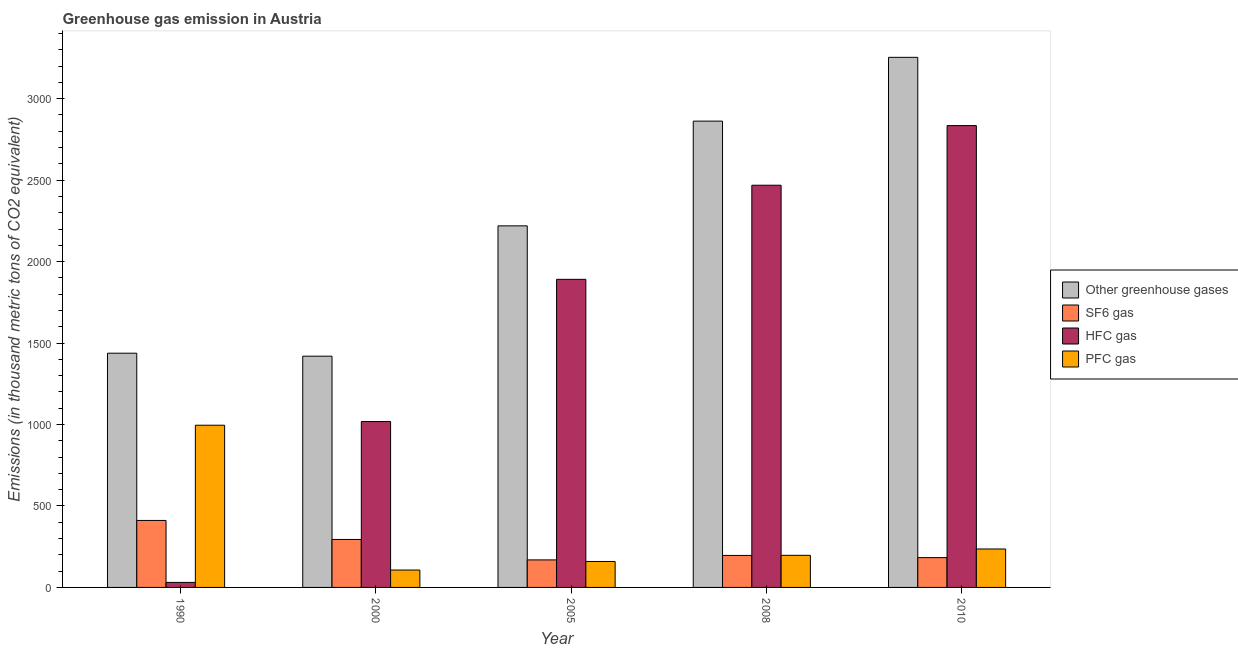How many bars are there on the 4th tick from the left?
Your answer should be very brief. 4. How many bars are there on the 1st tick from the right?
Your answer should be compact. 4. What is the label of the 2nd group of bars from the left?
Make the answer very short. 2000. What is the emission of pfc gas in 2010?
Offer a very short reply. 236. Across all years, what is the maximum emission of greenhouse gases?
Keep it short and to the point. 3254. Across all years, what is the minimum emission of hfc gas?
Your response must be concise. 30.9. In which year was the emission of pfc gas minimum?
Make the answer very short. 2000. What is the total emission of greenhouse gases in the graph?
Provide a short and direct response. 1.12e+04. What is the difference between the emission of hfc gas in 1990 and that in 2005?
Provide a succinct answer. -1860.3. What is the difference between the emission of hfc gas in 2008 and the emission of sf6 gas in 1990?
Your response must be concise. 2438. What is the average emission of sf6 gas per year?
Ensure brevity in your answer.  250.8. What is the ratio of the emission of greenhouse gases in 2000 to that in 2010?
Make the answer very short. 0.44. Is the emission of pfc gas in 1990 less than that in 2000?
Ensure brevity in your answer.  No. Is the difference between the emission of hfc gas in 1990 and 2010 greater than the difference between the emission of greenhouse gases in 1990 and 2010?
Provide a short and direct response. No. What is the difference between the highest and the second highest emission of pfc gas?
Provide a short and direct response. 759.7. What is the difference between the highest and the lowest emission of sf6 gas?
Provide a succinct answer. 242.2. What does the 3rd bar from the left in 2000 represents?
Provide a succinct answer. HFC gas. What does the 4th bar from the right in 2010 represents?
Provide a succinct answer. Other greenhouse gases. Is it the case that in every year, the sum of the emission of greenhouse gases and emission of sf6 gas is greater than the emission of hfc gas?
Your answer should be very brief. Yes. Are the values on the major ticks of Y-axis written in scientific E-notation?
Provide a succinct answer. No. Does the graph contain any zero values?
Ensure brevity in your answer.  No. Does the graph contain grids?
Your answer should be compact. No. How many legend labels are there?
Offer a very short reply. 4. What is the title of the graph?
Ensure brevity in your answer.  Greenhouse gas emission in Austria. Does "Secondary schools" appear as one of the legend labels in the graph?
Your answer should be compact. No. What is the label or title of the X-axis?
Ensure brevity in your answer.  Year. What is the label or title of the Y-axis?
Ensure brevity in your answer.  Emissions (in thousand metric tons of CO2 equivalent). What is the Emissions (in thousand metric tons of CO2 equivalent) in Other greenhouse gases in 1990?
Provide a short and direct response. 1437.8. What is the Emissions (in thousand metric tons of CO2 equivalent) of SF6 gas in 1990?
Offer a very short reply. 411.2. What is the Emissions (in thousand metric tons of CO2 equivalent) of HFC gas in 1990?
Provide a short and direct response. 30.9. What is the Emissions (in thousand metric tons of CO2 equivalent) in PFC gas in 1990?
Ensure brevity in your answer.  995.7. What is the Emissions (in thousand metric tons of CO2 equivalent) of Other greenhouse gases in 2000?
Provide a short and direct response. 1419.5. What is the Emissions (in thousand metric tons of CO2 equivalent) in SF6 gas in 2000?
Your response must be concise. 294.4. What is the Emissions (in thousand metric tons of CO2 equivalent) in HFC gas in 2000?
Make the answer very short. 1018.4. What is the Emissions (in thousand metric tons of CO2 equivalent) in PFC gas in 2000?
Offer a very short reply. 106.7. What is the Emissions (in thousand metric tons of CO2 equivalent) of Other greenhouse gases in 2005?
Your answer should be very brief. 2219.5. What is the Emissions (in thousand metric tons of CO2 equivalent) of SF6 gas in 2005?
Your answer should be very brief. 169. What is the Emissions (in thousand metric tons of CO2 equivalent) in HFC gas in 2005?
Offer a terse response. 1891.2. What is the Emissions (in thousand metric tons of CO2 equivalent) of PFC gas in 2005?
Offer a terse response. 159.3. What is the Emissions (in thousand metric tons of CO2 equivalent) of Other greenhouse gases in 2008?
Make the answer very short. 2862.4. What is the Emissions (in thousand metric tons of CO2 equivalent) of SF6 gas in 2008?
Keep it short and to the point. 196.4. What is the Emissions (in thousand metric tons of CO2 equivalent) in HFC gas in 2008?
Your response must be concise. 2468.9. What is the Emissions (in thousand metric tons of CO2 equivalent) of PFC gas in 2008?
Offer a very short reply. 197.1. What is the Emissions (in thousand metric tons of CO2 equivalent) of Other greenhouse gases in 2010?
Your response must be concise. 3254. What is the Emissions (in thousand metric tons of CO2 equivalent) in SF6 gas in 2010?
Provide a short and direct response. 183. What is the Emissions (in thousand metric tons of CO2 equivalent) of HFC gas in 2010?
Keep it short and to the point. 2835. What is the Emissions (in thousand metric tons of CO2 equivalent) of PFC gas in 2010?
Offer a very short reply. 236. Across all years, what is the maximum Emissions (in thousand metric tons of CO2 equivalent) of Other greenhouse gases?
Your answer should be very brief. 3254. Across all years, what is the maximum Emissions (in thousand metric tons of CO2 equivalent) in SF6 gas?
Your answer should be compact. 411.2. Across all years, what is the maximum Emissions (in thousand metric tons of CO2 equivalent) in HFC gas?
Your answer should be very brief. 2835. Across all years, what is the maximum Emissions (in thousand metric tons of CO2 equivalent) of PFC gas?
Your answer should be compact. 995.7. Across all years, what is the minimum Emissions (in thousand metric tons of CO2 equivalent) in Other greenhouse gases?
Your response must be concise. 1419.5. Across all years, what is the minimum Emissions (in thousand metric tons of CO2 equivalent) in SF6 gas?
Your response must be concise. 169. Across all years, what is the minimum Emissions (in thousand metric tons of CO2 equivalent) of HFC gas?
Give a very brief answer. 30.9. Across all years, what is the minimum Emissions (in thousand metric tons of CO2 equivalent) of PFC gas?
Offer a terse response. 106.7. What is the total Emissions (in thousand metric tons of CO2 equivalent) in Other greenhouse gases in the graph?
Ensure brevity in your answer.  1.12e+04. What is the total Emissions (in thousand metric tons of CO2 equivalent) of SF6 gas in the graph?
Keep it short and to the point. 1254. What is the total Emissions (in thousand metric tons of CO2 equivalent) of HFC gas in the graph?
Provide a succinct answer. 8244.4. What is the total Emissions (in thousand metric tons of CO2 equivalent) of PFC gas in the graph?
Offer a very short reply. 1694.8. What is the difference between the Emissions (in thousand metric tons of CO2 equivalent) in Other greenhouse gases in 1990 and that in 2000?
Provide a short and direct response. 18.3. What is the difference between the Emissions (in thousand metric tons of CO2 equivalent) in SF6 gas in 1990 and that in 2000?
Offer a terse response. 116.8. What is the difference between the Emissions (in thousand metric tons of CO2 equivalent) in HFC gas in 1990 and that in 2000?
Provide a succinct answer. -987.5. What is the difference between the Emissions (in thousand metric tons of CO2 equivalent) in PFC gas in 1990 and that in 2000?
Ensure brevity in your answer.  889. What is the difference between the Emissions (in thousand metric tons of CO2 equivalent) in Other greenhouse gases in 1990 and that in 2005?
Ensure brevity in your answer.  -781.7. What is the difference between the Emissions (in thousand metric tons of CO2 equivalent) in SF6 gas in 1990 and that in 2005?
Your response must be concise. 242.2. What is the difference between the Emissions (in thousand metric tons of CO2 equivalent) of HFC gas in 1990 and that in 2005?
Your response must be concise. -1860.3. What is the difference between the Emissions (in thousand metric tons of CO2 equivalent) in PFC gas in 1990 and that in 2005?
Your response must be concise. 836.4. What is the difference between the Emissions (in thousand metric tons of CO2 equivalent) of Other greenhouse gases in 1990 and that in 2008?
Offer a terse response. -1424.6. What is the difference between the Emissions (in thousand metric tons of CO2 equivalent) in SF6 gas in 1990 and that in 2008?
Give a very brief answer. 214.8. What is the difference between the Emissions (in thousand metric tons of CO2 equivalent) of HFC gas in 1990 and that in 2008?
Give a very brief answer. -2438. What is the difference between the Emissions (in thousand metric tons of CO2 equivalent) of PFC gas in 1990 and that in 2008?
Provide a short and direct response. 798.6. What is the difference between the Emissions (in thousand metric tons of CO2 equivalent) of Other greenhouse gases in 1990 and that in 2010?
Your answer should be very brief. -1816.2. What is the difference between the Emissions (in thousand metric tons of CO2 equivalent) of SF6 gas in 1990 and that in 2010?
Provide a succinct answer. 228.2. What is the difference between the Emissions (in thousand metric tons of CO2 equivalent) in HFC gas in 1990 and that in 2010?
Give a very brief answer. -2804.1. What is the difference between the Emissions (in thousand metric tons of CO2 equivalent) of PFC gas in 1990 and that in 2010?
Your response must be concise. 759.7. What is the difference between the Emissions (in thousand metric tons of CO2 equivalent) of Other greenhouse gases in 2000 and that in 2005?
Keep it short and to the point. -800. What is the difference between the Emissions (in thousand metric tons of CO2 equivalent) of SF6 gas in 2000 and that in 2005?
Provide a short and direct response. 125.4. What is the difference between the Emissions (in thousand metric tons of CO2 equivalent) in HFC gas in 2000 and that in 2005?
Provide a succinct answer. -872.8. What is the difference between the Emissions (in thousand metric tons of CO2 equivalent) of PFC gas in 2000 and that in 2005?
Your answer should be very brief. -52.6. What is the difference between the Emissions (in thousand metric tons of CO2 equivalent) in Other greenhouse gases in 2000 and that in 2008?
Your answer should be very brief. -1442.9. What is the difference between the Emissions (in thousand metric tons of CO2 equivalent) in HFC gas in 2000 and that in 2008?
Give a very brief answer. -1450.5. What is the difference between the Emissions (in thousand metric tons of CO2 equivalent) of PFC gas in 2000 and that in 2008?
Offer a terse response. -90.4. What is the difference between the Emissions (in thousand metric tons of CO2 equivalent) of Other greenhouse gases in 2000 and that in 2010?
Your answer should be very brief. -1834.5. What is the difference between the Emissions (in thousand metric tons of CO2 equivalent) in SF6 gas in 2000 and that in 2010?
Provide a short and direct response. 111.4. What is the difference between the Emissions (in thousand metric tons of CO2 equivalent) of HFC gas in 2000 and that in 2010?
Offer a very short reply. -1816.6. What is the difference between the Emissions (in thousand metric tons of CO2 equivalent) of PFC gas in 2000 and that in 2010?
Offer a very short reply. -129.3. What is the difference between the Emissions (in thousand metric tons of CO2 equivalent) in Other greenhouse gases in 2005 and that in 2008?
Make the answer very short. -642.9. What is the difference between the Emissions (in thousand metric tons of CO2 equivalent) of SF6 gas in 2005 and that in 2008?
Your answer should be very brief. -27.4. What is the difference between the Emissions (in thousand metric tons of CO2 equivalent) of HFC gas in 2005 and that in 2008?
Provide a short and direct response. -577.7. What is the difference between the Emissions (in thousand metric tons of CO2 equivalent) in PFC gas in 2005 and that in 2008?
Offer a terse response. -37.8. What is the difference between the Emissions (in thousand metric tons of CO2 equivalent) in Other greenhouse gases in 2005 and that in 2010?
Keep it short and to the point. -1034.5. What is the difference between the Emissions (in thousand metric tons of CO2 equivalent) of HFC gas in 2005 and that in 2010?
Give a very brief answer. -943.8. What is the difference between the Emissions (in thousand metric tons of CO2 equivalent) of PFC gas in 2005 and that in 2010?
Provide a succinct answer. -76.7. What is the difference between the Emissions (in thousand metric tons of CO2 equivalent) of Other greenhouse gases in 2008 and that in 2010?
Give a very brief answer. -391.6. What is the difference between the Emissions (in thousand metric tons of CO2 equivalent) of SF6 gas in 2008 and that in 2010?
Keep it short and to the point. 13.4. What is the difference between the Emissions (in thousand metric tons of CO2 equivalent) in HFC gas in 2008 and that in 2010?
Give a very brief answer. -366.1. What is the difference between the Emissions (in thousand metric tons of CO2 equivalent) in PFC gas in 2008 and that in 2010?
Offer a terse response. -38.9. What is the difference between the Emissions (in thousand metric tons of CO2 equivalent) of Other greenhouse gases in 1990 and the Emissions (in thousand metric tons of CO2 equivalent) of SF6 gas in 2000?
Offer a terse response. 1143.4. What is the difference between the Emissions (in thousand metric tons of CO2 equivalent) of Other greenhouse gases in 1990 and the Emissions (in thousand metric tons of CO2 equivalent) of HFC gas in 2000?
Offer a very short reply. 419.4. What is the difference between the Emissions (in thousand metric tons of CO2 equivalent) of Other greenhouse gases in 1990 and the Emissions (in thousand metric tons of CO2 equivalent) of PFC gas in 2000?
Ensure brevity in your answer.  1331.1. What is the difference between the Emissions (in thousand metric tons of CO2 equivalent) in SF6 gas in 1990 and the Emissions (in thousand metric tons of CO2 equivalent) in HFC gas in 2000?
Your response must be concise. -607.2. What is the difference between the Emissions (in thousand metric tons of CO2 equivalent) of SF6 gas in 1990 and the Emissions (in thousand metric tons of CO2 equivalent) of PFC gas in 2000?
Make the answer very short. 304.5. What is the difference between the Emissions (in thousand metric tons of CO2 equivalent) in HFC gas in 1990 and the Emissions (in thousand metric tons of CO2 equivalent) in PFC gas in 2000?
Your response must be concise. -75.8. What is the difference between the Emissions (in thousand metric tons of CO2 equivalent) in Other greenhouse gases in 1990 and the Emissions (in thousand metric tons of CO2 equivalent) in SF6 gas in 2005?
Your answer should be compact. 1268.8. What is the difference between the Emissions (in thousand metric tons of CO2 equivalent) of Other greenhouse gases in 1990 and the Emissions (in thousand metric tons of CO2 equivalent) of HFC gas in 2005?
Provide a short and direct response. -453.4. What is the difference between the Emissions (in thousand metric tons of CO2 equivalent) of Other greenhouse gases in 1990 and the Emissions (in thousand metric tons of CO2 equivalent) of PFC gas in 2005?
Offer a terse response. 1278.5. What is the difference between the Emissions (in thousand metric tons of CO2 equivalent) in SF6 gas in 1990 and the Emissions (in thousand metric tons of CO2 equivalent) in HFC gas in 2005?
Provide a short and direct response. -1480. What is the difference between the Emissions (in thousand metric tons of CO2 equivalent) in SF6 gas in 1990 and the Emissions (in thousand metric tons of CO2 equivalent) in PFC gas in 2005?
Offer a terse response. 251.9. What is the difference between the Emissions (in thousand metric tons of CO2 equivalent) of HFC gas in 1990 and the Emissions (in thousand metric tons of CO2 equivalent) of PFC gas in 2005?
Offer a very short reply. -128.4. What is the difference between the Emissions (in thousand metric tons of CO2 equivalent) of Other greenhouse gases in 1990 and the Emissions (in thousand metric tons of CO2 equivalent) of SF6 gas in 2008?
Your answer should be compact. 1241.4. What is the difference between the Emissions (in thousand metric tons of CO2 equivalent) in Other greenhouse gases in 1990 and the Emissions (in thousand metric tons of CO2 equivalent) in HFC gas in 2008?
Offer a very short reply. -1031.1. What is the difference between the Emissions (in thousand metric tons of CO2 equivalent) in Other greenhouse gases in 1990 and the Emissions (in thousand metric tons of CO2 equivalent) in PFC gas in 2008?
Provide a short and direct response. 1240.7. What is the difference between the Emissions (in thousand metric tons of CO2 equivalent) in SF6 gas in 1990 and the Emissions (in thousand metric tons of CO2 equivalent) in HFC gas in 2008?
Give a very brief answer. -2057.7. What is the difference between the Emissions (in thousand metric tons of CO2 equivalent) in SF6 gas in 1990 and the Emissions (in thousand metric tons of CO2 equivalent) in PFC gas in 2008?
Your answer should be very brief. 214.1. What is the difference between the Emissions (in thousand metric tons of CO2 equivalent) in HFC gas in 1990 and the Emissions (in thousand metric tons of CO2 equivalent) in PFC gas in 2008?
Provide a succinct answer. -166.2. What is the difference between the Emissions (in thousand metric tons of CO2 equivalent) of Other greenhouse gases in 1990 and the Emissions (in thousand metric tons of CO2 equivalent) of SF6 gas in 2010?
Offer a very short reply. 1254.8. What is the difference between the Emissions (in thousand metric tons of CO2 equivalent) in Other greenhouse gases in 1990 and the Emissions (in thousand metric tons of CO2 equivalent) in HFC gas in 2010?
Offer a very short reply. -1397.2. What is the difference between the Emissions (in thousand metric tons of CO2 equivalent) of Other greenhouse gases in 1990 and the Emissions (in thousand metric tons of CO2 equivalent) of PFC gas in 2010?
Ensure brevity in your answer.  1201.8. What is the difference between the Emissions (in thousand metric tons of CO2 equivalent) of SF6 gas in 1990 and the Emissions (in thousand metric tons of CO2 equivalent) of HFC gas in 2010?
Your answer should be very brief. -2423.8. What is the difference between the Emissions (in thousand metric tons of CO2 equivalent) in SF6 gas in 1990 and the Emissions (in thousand metric tons of CO2 equivalent) in PFC gas in 2010?
Give a very brief answer. 175.2. What is the difference between the Emissions (in thousand metric tons of CO2 equivalent) of HFC gas in 1990 and the Emissions (in thousand metric tons of CO2 equivalent) of PFC gas in 2010?
Keep it short and to the point. -205.1. What is the difference between the Emissions (in thousand metric tons of CO2 equivalent) in Other greenhouse gases in 2000 and the Emissions (in thousand metric tons of CO2 equivalent) in SF6 gas in 2005?
Give a very brief answer. 1250.5. What is the difference between the Emissions (in thousand metric tons of CO2 equivalent) of Other greenhouse gases in 2000 and the Emissions (in thousand metric tons of CO2 equivalent) of HFC gas in 2005?
Your answer should be very brief. -471.7. What is the difference between the Emissions (in thousand metric tons of CO2 equivalent) in Other greenhouse gases in 2000 and the Emissions (in thousand metric tons of CO2 equivalent) in PFC gas in 2005?
Ensure brevity in your answer.  1260.2. What is the difference between the Emissions (in thousand metric tons of CO2 equivalent) in SF6 gas in 2000 and the Emissions (in thousand metric tons of CO2 equivalent) in HFC gas in 2005?
Offer a very short reply. -1596.8. What is the difference between the Emissions (in thousand metric tons of CO2 equivalent) of SF6 gas in 2000 and the Emissions (in thousand metric tons of CO2 equivalent) of PFC gas in 2005?
Your response must be concise. 135.1. What is the difference between the Emissions (in thousand metric tons of CO2 equivalent) in HFC gas in 2000 and the Emissions (in thousand metric tons of CO2 equivalent) in PFC gas in 2005?
Provide a short and direct response. 859.1. What is the difference between the Emissions (in thousand metric tons of CO2 equivalent) of Other greenhouse gases in 2000 and the Emissions (in thousand metric tons of CO2 equivalent) of SF6 gas in 2008?
Offer a terse response. 1223.1. What is the difference between the Emissions (in thousand metric tons of CO2 equivalent) of Other greenhouse gases in 2000 and the Emissions (in thousand metric tons of CO2 equivalent) of HFC gas in 2008?
Your answer should be very brief. -1049.4. What is the difference between the Emissions (in thousand metric tons of CO2 equivalent) in Other greenhouse gases in 2000 and the Emissions (in thousand metric tons of CO2 equivalent) in PFC gas in 2008?
Provide a short and direct response. 1222.4. What is the difference between the Emissions (in thousand metric tons of CO2 equivalent) in SF6 gas in 2000 and the Emissions (in thousand metric tons of CO2 equivalent) in HFC gas in 2008?
Provide a succinct answer. -2174.5. What is the difference between the Emissions (in thousand metric tons of CO2 equivalent) in SF6 gas in 2000 and the Emissions (in thousand metric tons of CO2 equivalent) in PFC gas in 2008?
Provide a succinct answer. 97.3. What is the difference between the Emissions (in thousand metric tons of CO2 equivalent) in HFC gas in 2000 and the Emissions (in thousand metric tons of CO2 equivalent) in PFC gas in 2008?
Make the answer very short. 821.3. What is the difference between the Emissions (in thousand metric tons of CO2 equivalent) in Other greenhouse gases in 2000 and the Emissions (in thousand metric tons of CO2 equivalent) in SF6 gas in 2010?
Your answer should be compact. 1236.5. What is the difference between the Emissions (in thousand metric tons of CO2 equivalent) in Other greenhouse gases in 2000 and the Emissions (in thousand metric tons of CO2 equivalent) in HFC gas in 2010?
Your answer should be compact. -1415.5. What is the difference between the Emissions (in thousand metric tons of CO2 equivalent) in Other greenhouse gases in 2000 and the Emissions (in thousand metric tons of CO2 equivalent) in PFC gas in 2010?
Offer a very short reply. 1183.5. What is the difference between the Emissions (in thousand metric tons of CO2 equivalent) in SF6 gas in 2000 and the Emissions (in thousand metric tons of CO2 equivalent) in HFC gas in 2010?
Give a very brief answer. -2540.6. What is the difference between the Emissions (in thousand metric tons of CO2 equivalent) of SF6 gas in 2000 and the Emissions (in thousand metric tons of CO2 equivalent) of PFC gas in 2010?
Keep it short and to the point. 58.4. What is the difference between the Emissions (in thousand metric tons of CO2 equivalent) of HFC gas in 2000 and the Emissions (in thousand metric tons of CO2 equivalent) of PFC gas in 2010?
Provide a succinct answer. 782.4. What is the difference between the Emissions (in thousand metric tons of CO2 equivalent) of Other greenhouse gases in 2005 and the Emissions (in thousand metric tons of CO2 equivalent) of SF6 gas in 2008?
Your response must be concise. 2023.1. What is the difference between the Emissions (in thousand metric tons of CO2 equivalent) of Other greenhouse gases in 2005 and the Emissions (in thousand metric tons of CO2 equivalent) of HFC gas in 2008?
Ensure brevity in your answer.  -249.4. What is the difference between the Emissions (in thousand metric tons of CO2 equivalent) of Other greenhouse gases in 2005 and the Emissions (in thousand metric tons of CO2 equivalent) of PFC gas in 2008?
Offer a terse response. 2022.4. What is the difference between the Emissions (in thousand metric tons of CO2 equivalent) of SF6 gas in 2005 and the Emissions (in thousand metric tons of CO2 equivalent) of HFC gas in 2008?
Your response must be concise. -2299.9. What is the difference between the Emissions (in thousand metric tons of CO2 equivalent) of SF6 gas in 2005 and the Emissions (in thousand metric tons of CO2 equivalent) of PFC gas in 2008?
Offer a very short reply. -28.1. What is the difference between the Emissions (in thousand metric tons of CO2 equivalent) of HFC gas in 2005 and the Emissions (in thousand metric tons of CO2 equivalent) of PFC gas in 2008?
Offer a very short reply. 1694.1. What is the difference between the Emissions (in thousand metric tons of CO2 equivalent) of Other greenhouse gases in 2005 and the Emissions (in thousand metric tons of CO2 equivalent) of SF6 gas in 2010?
Your answer should be very brief. 2036.5. What is the difference between the Emissions (in thousand metric tons of CO2 equivalent) of Other greenhouse gases in 2005 and the Emissions (in thousand metric tons of CO2 equivalent) of HFC gas in 2010?
Provide a succinct answer. -615.5. What is the difference between the Emissions (in thousand metric tons of CO2 equivalent) of Other greenhouse gases in 2005 and the Emissions (in thousand metric tons of CO2 equivalent) of PFC gas in 2010?
Provide a short and direct response. 1983.5. What is the difference between the Emissions (in thousand metric tons of CO2 equivalent) of SF6 gas in 2005 and the Emissions (in thousand metric tons of CO2 equivalent) of HFC gas in 2010?
Your response must be concise. -2666. What is the difference between the Emissions (in thousand metric tons of CO2 equivalent) in SF6 gas in 2005 and the Emissions (in thousand metric tons of CO2 equivalent) in PFC gas in 2010?
Provide a succinct answer. -67. What is the difference between the Emissions (in thousand metric tons of CO2 equivalent) of HFC gas in 2005 and the Emissions (in thousand metric tons of CO2 equivalent) of PFC gas in 2010?
Provide a short and direct response. 1655.2. What is the difference between the Emissions (in thousand metric tons of CO2 equivalent) in Other greenhouse gases in 2008 and the Emissions (in thousand metric tons of CO2 equivalent) in SF6 gas in 2010?
Your answer should be very brief. 2679.4. What is the difference between the Emissions (in thousand metric tons of CO2 equivalent) in Other greenhouse gases in 2008 and the Emissions (in thousand metric tons of CO2 equivalent) in HFC gas in 2010?
Offer a terse response. 27.4. What is the difference between the Emissions (in thousand metric tons of CO2 equivalent) of Other greenhouse gases in 2008 and the Emissions (in thousand metric tons of CO2 equivalent) of PFC gas in 2010?
Your answer should be very brief. 2626.4. What is the difference between the Emissions (in thousand metric tons of CO2 equivalent) of SF6 gas in 2008 and the Emissions (in thousand metric tons of CO2 equivalent) of HFC gas in 2010?
Ensure brevity in your answer.  -2638.6. What is the difference between the Emissions (in thousand metric tons of CO2 equivalent) in SF6 gas in 2008 and the Emissions (in thousand metric tons of CO2 equivalent) in PFC gas in 2010?
Your answer should be very brief. -39.6. What is the difference between the Emissions (in thousand metric tons of CO2 equivalent) in HFC gas in 2008 and the Emissions (in thousand metric tons of CO2 equivalent) in PFC gas in 2010?
Your answer should be very brief. 2232.9. What is the average Emissions (in thousand metric tons of CO2 equivalent) of Other greenhouse gases per year?
Your answer should be compact. 2238.64. What is the average Emissions (in thousand metric tons of CO2 equivalent) of SF6 gas per year?
Your response must be concise. 250.8. What is the average Emissions (in thousand metric tons of CO2 equivalent) of HFC gas per year?
Provide a short and direct response. 1648.88. What is the average Emissions (in thousand metric tons of CO2 equivalent) of PFC gas per year?
Offer a very short reply. 338.96. In the year 1990, what is the difference between the Emissions (in thousand metric tons of CO2 equivalent) of Other greenhouse gases and Emissions (in thousand metric tons of CO2 equivalent) of SF6 gas?
Offer a very short reply. 1026.6. In the year 1990, what is the difference between the Emissions (in thousand metric tons of CO2 equivalent) of Other greenhouse gases and Emissions (in thousand metric tons of CO2 equivalent) of HFC gas?
Your answer should be compact. 1406.9. In the year 1990, what is the difference between the Emissions (in thousand metric tons of CO2 equivalent) in Other greenhouse gases and Emissions (in thousand metric tons of CO2 equivalent) in PFC gas?
Provide a short and direct response. 442.1. In the year 1990, what is the difference between the Emissions (in thousand metric tons of CO2 equivalent) of SF6 gas and Emissions (in thousand metric tons of CO2 equivalent) of HFC gas?
Your answer should be very brief. 380.3. In the year 1990, what is the difference between the Emissions (in thousand metric tons of CO2 equivalent) in SF6 gas and Emissions (in thousand metric tons of CO2 equivalent) in PFC gas?
Ensure brevity in your answer.  -584.5. In the year 1990, what is the difference between the Emissions (in thousand metric tons of CO2 equivalent) in HFC gas and Emissions (in thousand metric tons of CO2 equivalent) in PFC gas?
Your response must be concise. -964.8. In the year 2000, what is the difference between the Emissions (in thousand metric tons of CO2 equivalent) in Other greenhouse gases and Emissions (in thousand metric tons of CO2 equivalent) in SF6 gas?
Your answer should be very brief. 1125.1. In the year 2000, what is the difference between the Emissions (in thousand metric tons of CO2 equivalent) of Other greenhouse gases and Emissions (in thousand metric tons of CO2 equivalent) of HFC gas?
Your response must be concise. 401.1. In the year 2000, what is the difference between the Emissions (in thousand metric tons of CO2 equivalent) of Other greenhouse gases and Emissions (in thousand metric tons of CO2 equivalent) of PFC gas?
Your answer should be compact. 1312.8. In the year 2000, what is the difference between the Emissions (in thousand metric tons of CO2 equivalent) of SF6 gas and Emissions (in thousand metric tons of CO2 equivalent) of HFC gas?
Keep it short and to the point. -724. In the year 2000, what is the difference between the Emissions (in thousand metric tons of CO2 equivalent) of SF6 gas and Emissions (in thousand metric tons of CO2 equivalent) of PFC gas?
Keep it short and to the point. 187.7. In the year 2000, what is the difference between the Emissions (in thousand metric tons of CO2 equivalent) of HFC gas and Emissions (in thousand metric tons of CO2 equivalent) of PFC gas?
Provide a succinct answer. 911.7. In the year 2005, what is the difference between the Emissions (in thousand metric tons of CO2 equivalent) of Other greenhouse gases and Emissions (in thousand metric tons of CO2 equivalent) of SF6 gas?
Offer a terse response. 2050.5. In the year 2005, what is the difference between the Emissions (in thousand metric tons of CO2 equivalent) in Other greenhouse gases and Emissions (in thousand metric tons of CO2 equivalent) in HFC gas?
Make the answer very short. 328.3. In the year 2005, what is the difference between the Emissions (in thousand metric tons of CO2 equivalent) of Other greenhouse gases and Emissions (in thousand metric tons of CO2 equivalent) of PFC gas?
Offer a very short reply. 2060.2. In the year 2005, what is the difference between the Emissions (in thousand metric tons of CO2 equivalent) in SF6 gas and Emissions (in thousand metric tons of CO2 equivalent) in HFC gas?
Offer a terse response. -1722.2. In the year 2005, what is the difference between the Emissions (in thousand metric tons of CO2 equivalent) of SF6 gas and Emissions (in thousand metric tons of CO2 equivalent) of PFC gas?
Ensure brevity in your answer.  9.7. In the year 2005, what is the difference between the Emissions (in thousand metric tons of CO2 equivalent) in HFC gas and Emissions (in thousand metric tons of CO2 equivalent) in PFC gas?
Ensure brevity in your answer.  1731.9. In the year 2008, what is the difference between the Emissions (in thousand metric tons of CO2 equivalent) in Other greenhouse gases and Emissions (in thousand metric tons of CO2 equivalent) in SF6 gas?
Offer a terse response. 2666. In the year 2008, what is the difference between the Emissions (in thousand metric tons of CO2 equivalent) of Other greenhouse gases and Emissions (in thousand metric tons of CO2 equivalent) of HFC gas?
Offer a terse response. 393.5. In the year 2008, what is the difference between the Emissions (in thousand metric tons of CO2 equivalent) in Other greenhouse gases and Emissions (in thousand metric tons of CO2 equivalent) in PFC gas?
Give a very brief answer. 2665.3. In the year 2008, what is the difference between the Emissions (in thousand metric tons of CO2 equivalent) of SF6 gas and Emissions (in thousand metric tons of CO2 equivalent) of HFC gas?
Your answer should be very brief. -2272.5. In the year 2008, what is the difference between the Emissions (in thousand metric tons of CO2 equivalent) of HFC gas and Emissions (in thousand metric tons of CO2 equivalent) of PFC gas?
Ensure brevity in your answer.  2271.8. In the year 2010, what is the difference between the Emissions (in thousand metric tons of CO2 equivalent) of Other greenhouse gases and Emissions (in thousand metric tons of CO2 equivalent) of SF6 gas?
Provide a short and direct response. 3071. In the year 2010, what is the difference between the Emissions (in thousand metric tons of CO2 equivalent) of Other greenhouse gases and Emissions (in thousand metric tons of CO2 equivalent) of HFC gas?
Your response must be concise. 419. In the year 2010, what is the difference between the Emissions (in thousand metric tons of CO2 equivalent) of Other greenhouse gases and Emissions (in thousand metric tons of CO2 equivalent) of PFC gas?
Your answer should be compact. 3018. In the year 2010, what is the difference between the Emissions (in thousand metric tons of CO2 equivalent) of SF6 gas and Emissions (in thousand metric tons of CO2 equivalent) of HFC gas?
Keep it short and to the point. -2652. In the year 2010, what is the difference between the Emissions (in thousand metric tons of CO2 equivalent) in SF6 gas and Emissions (in thousand metric tons of CO2 equivalent) in PFC gas?
Give a very brief answer. -53. In the year 2010, what is the difference between the Emissions (in thousand metric tons of CO2 equivalent) in HFC gas and Emissions (in thousand metric tons of CO2 equivalent) in PFC gas?
Keep it short and to the point. 2599. What is the ratio of the Emissions (in thousand metric tons of CO2 equivalent) of Other greenhouse gases in 1990 to that in 2000?
Your answer should be compact. 1.01. What is the ratio of the Emissions (in thousand metric tons of CO2 equivalent) in SF6 gas in 1990 to that in 2000?
Offer a terse response. 1.4. What is the ratio of the Emissions (in thousand metric tons of CO2 equivalent) of HFC gas in 1990 to that in 2000?
Keep it short and to the point. 0.03. What is the ratio of the Emissions (in thousand metric tons of CO2 equivalent) of PFC gas in 1990 to that in 2000?
Give a very brief answer. 9.33. What is the ratio of the Emissions (in thousand metric tons of CO2 equivalent) of Other greenhouse gases in 1990 to that in 2005?
Offer a terse response. 0.65. What is the ratio of the Emissions (in thousand metric tons of CO2 equivalent) in SF6 gas in 1990 to that in 2005?
Your answer should be very brief. 2.43. What is the ratio of the Emissions (in thousand metric tons of CO2 equivalent) in HFC gas in 1990 to that in 2005?
Your response must be concise. 0.02. What is the ratio of the Emissions (in thousand metric tons of CO2 equivalent) of PFC gas in 1990 to that in 2005?
Your answer should be compact. 6.25. What is the ratio of the Emissions (in thousand metric tons of CO2 equivalent) in Other greenhouse gases in 1990 to that in 2008?
Offer a terse response. 0.5. What is the ratio of the Emissions (in thousand metric tons of CO2 equivalent) in SF6 gas in 1990 to that in 2008?
Keep it short and to the point. 2.09. What is the ratio of the Emissions (in thousand metric tons of CO2 equivalent) of HFC gas in 1990 to that in 2008?
Make the answer very short. 0.01. What is the ratio of the Emissions (in thousand metric tons of CO2 equivalent) in PFC gas in 1990 to that in 2008?
Offer a very short reply. 5.05. What is the ratio of the Emissions (in thousand metric tons of CO2 equivalent) in Other greenhouse gases in 1990 to that in 2010?
Your response must be concise. 0.44. What is the ratio of the Emissions (in thousand metric tons of CO2 equivalent) of SF6 gas in 1990 to that in 2010?
Provide a short and direct response. 2.25. What is the ratio of the Emissions (in thousand metric tons of CO2 equivalent) of HFC gas in 1990 to that in 2010?
Offer a very short reply. 0.01. What is the ratio of the Emissions (in thousand metric tons of CO2 equivalent) of PFC gas in 1990 to that in 2010?
Provide a succinct answer. 4.22. What is the ratio of the Emissions (in thousand metric tons of CO2 equivalent) in Other greenhouse gases in 2000 to that in 2005?
Your answer should be compact. 0.64. What is the ratio of the Emissions (in thousand metric tons of CO2 equivalent) of SF6 gas in 2000 to that in 2005?
Your answer should be compact. 1.74. What is the ratio of the Emissions (in thousand metric tons of CO2 equivalent) of HFC gas in 2000 to that in 2005?
Offer a very short reply. 0.54. What is the ratio of the Emissions (in thousand metric tons of CO2 equivalent) in PFC gas in 2000 to that in 2005?
Make the answer very short. 0.67. What is the ratio of the Emissions (in thousand metric tons of CO2 equivalent) of Other greenhouse gases in 2000 to that in 2008?
Ensure brevity in your answer.  0.5. What is the ratio of the Emissions (in thousand metric tons of CO2 equivalent) in SF6 gas in 2000 to that in 2008?
Ensure brevity in your answer.  1.5. What is the ratio of the Emissions (in thousand metric tons of CO2 equivalent) in HFC gas in 2000 to that in 2008?
Provide a short and direct response. 0.41. What is the ratio of the Emissions (in thousand metric tons of CO2 equivalent) of PFC gas in 2000 to that in 2008?
Give a very brief answer. 0.54. What is the ratio of the Emissions (in thousand metric tons of CO2 equivalent) of Other greenhouse gases in 2000 to that in 2010?
Provide a succinct answer. 0.44. What is the ratio of the Emissions (in thousand metric tons of CO2 equivalent) in SF6 gas in 2000 to that in 2010?
Ensure brevity in your answer.  1.61. What is the ratio of the Emissions (in thousand metric tons of CO2 equivalent) in HFC gas in 2000 to that in 2010?
Your answer should be very brief. 0.36. What is the ratio of the Emissions (in thousand metric tons of CO2 equivalent) of PFC gas in 2000 to that in 2010?
Offer a very short reply. 0.45. What is the ratio of the Emissions (in thousand metric tons of CO2 equivalent) in Other greenhouse gases in 2005 to that in 2008?
Ensure brevity in your answer.  0.78. What is the ratio of the Emissions (in thousand metric tons of CO2 equivalent) of SF6 gas in 2005 to that in 2008?
Make the answer very short. 0.86. What is the ratio of the Emissions (in thousand metric tons of CO2 equivalent) in HFC gas in 2005 to that in 2008?
Give a very brief answer. 0.77. What is the ratio of the Emissions (in thousand metric tons of CO2 equivalent) in PFC gas in 2005 to that in 2008?
Your answer should be compact. 0.81. What is the ratio of the Emissions (in thousand metric tons of CO2 equivalent) in Other greenhouse gases in 2005 to that in 2010?
Provide a short and direct response. 0.68. What is the ratio of the Emissions (in thousand metric tons of CO2 equivalent) in SF6 gas in 2005 to that in 2010?
Keep it short and to the point. 0.92. What is the ratio of the Emissions (in thousand metric tons of CO2 equivalent) in HFC gas in 2005 to that in 2010?
Provide a succinct answer. 0.67. What is the ratio of the Emissions (in thousand metric tons of CO2 equivalent) in PFC gas in 2005 to that in 2010?
Offer a very short reply. 0.68. What is the ratio of the Emissions (in thousand metric tons of CO2 equivalent) in Other greenhouse gases in 2008 to that in 2010?
Offer a very short reply. 0.88. What is the ratio of the Emissions (in thousand metric tons of CO2 equivalent) of SF6 gas in 2008 to that in 2010?
Your answer should be compact. 1.07. What is the ratio of the Emissions (in thousand metric tons of CO2 equivalent) of HFC gas in 2008 to that in 2010?
Provide a short and direct response. 0.87. What is the ratio of the Emissions (in thousand metric tons of CO2 equivalent) of PFC gas in 2008 to that in 2010?
Give a very brief answer. 0.84. What is the difference between the highest and the second highest Emissions (in thousand metric tons of CO2 equivalent) of Other greenhouse gases?
Offer a terse response. 391.6. What is the difference between the highest and the second highest Emissions (in thousand metric tons of CO2 equivalent) of SF6 gas?
Make the answer very short. 116.8. What is the difference between the highest and the second highest Emissions (in thousand metric tons of CO2 equivalent) in HFC gas?
Offer a terse response. 366.1. What is the difference between the highest and the second highest Emissions (in thousand metric tons of CO2 equivalent) of PFC gas?
Offer a very short reply. 759.7. What is the difference between the highest and the lowest Emissions (in thousand metric tons of CO2 equivalent) in Other greenhouse gases?
Provide a short and direct response. 1834.5. What is the difference between the highest and the lowest Emissions (in thousand metric tons of CO2 equivalent) in SF6 gas?
Your answer should be very brief. 242.2. What is the difference between the highest and the lowest Emissions (in thousand metric tons of CO2 equivalent) in HFC gas?
Keep it short and to the point. 2804.1. What is the difference between the highest and the lowest Emissions (in thousand metric tons of CO2 equivalent) in PFC gas?
Offer a very short reply. 889. 